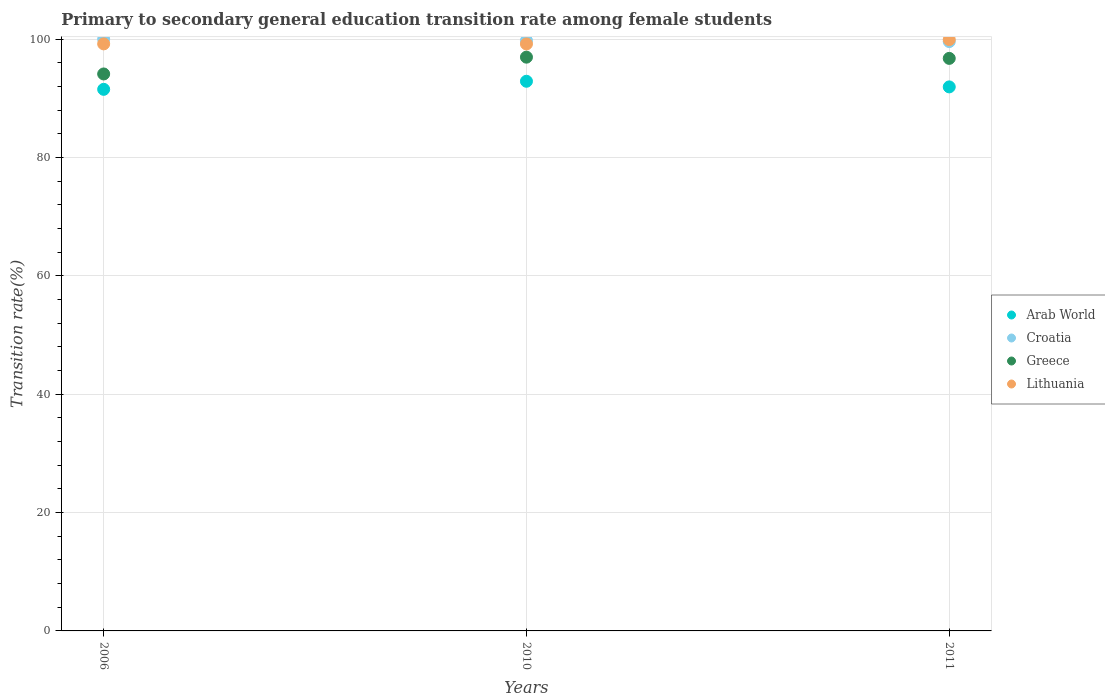What is the transition rate in Croatia in 2011?
Your answer should be very brief. 99.58. Across all years, what is the maximum transition rate in Greece?
Give a very brief answer. 96.95. Across all years, what is the minimum transition rate in Arab World?
Offer a terse response. 91.51. In which year was the transition rate in Lithuania minimum?
Your answer should be very brief. 2010. What is the total transition rate in Greece in the graph?
Provide a succinct answer. 287.79. What is the difference between the transition rate in Lithuania in 2010 and that in 2011?
Keep it short and to the point. -0.74. What is the difference between the transition rate in Arab World in 2011 and the transition rate in Croatia in 2010?
Offer a terse response. -7.83. What is the average transition rate in Croatia per year?
Your response must be concise. 99.78. In the year 2006, what is the difference between the transition rate in Greece and transition rate in Lithuania?
Provide a short and direct response. -5.08. In how many years, is the transition rate in Greece greater than 84 %?
Keep it short and to the point. 3. What is the ratio of the transition rate in Arab World in 2006 to that in 2010?
Provide a succinct answer. 0.99. Is the difference between the transition rate in Greece in 2006 and 2011 greater than the difference between the transition rate in Lithuania in 2006 and 2011?
Provide a succinct answer. No. What is the difference between the highest and the second highest transition rate in Croatia?
Give a very brief answer. 0.25. What is the difference between the highest and the lowest transition rate in Lithuania?
Provide a succinct answer. 0.74. Is the sum of the transition rate in Greece in 2010 and 2011 greater than the maximum transition rate in Lithuania across all years?
Your answer should be compact. Yes. Is it the case that in every year, the sum of the transition rate in Arab World and transition rate in Lithuania  is greater than the sum of transition rate in Croatia and transition rate in Greece?
Offer a very short reply. No. Does the transition rate in Lithuania monotonically increase over the years?
Make the answer very short. No. How many dotlines are there?
Offer a terse response. 4. What is the difference between two consecutive major ticks on the Y-axis?
Keep it short and to the point. 20. What is the title of the graph?
Offer a very short reply. Primary to secondary general education transition rate among female students. What is the label or title of the X-axis?
Ensure brevity in your answer.  Years. What is the label or title of the Y-axis?
Make the answer very short. Transition rate(%). What is the Transition rate(%) in Arab World in 2006?
Provide a succinct answer. 91.51. What is the Transition rate(%) in Greece in 2006?
Ensure brevity in your answer.  94.11. What is the Transition rate(%) of Lithuania in 2006?
Ensure brevity in your answer.  99.19. What is the Transition rate(%) of Arab World in 2010?
Your response must be concise. 92.87. What is the Transition rate(%) in Croatia in 2010?
Offer a terse response. 99.75. What is the Transition rate(%) of Greece in 2010?
Provide a succinct answer. 96.95. What is the Transition rate(%) of Lithuania in 2010?
Ensure brevity in your answer.  99.18. What is the Transition rate(%) in Arab World in 2011?
Your response must be concise. 91.92. What is the Transition rate(%) in Croatia in 2011?
Keep it short and to the point. 99.58. What is the Transition rate(%) in Greece in 2011?
Make the answer very short. 96.74. What is the Transition rate(%) in Lithuania in 2011?
Provide a succinct answer. 99.92. Across all years, what is the maximum Transition rate(%) of Arab World?
Your answer should be compact. 92.87. Across all years, what is the maximum Transition rate(%) of Greece?
Offer a very short reply. 96.95. Across all years, what is the maximum Transition rate(%) in Lithuania?
Provide a short and direct response. 99.92. Across all years, what is the minimum Transition rate(%) of Arab World?
Provide a succinct answer. 91.51. Across all years, what is the minimum Transition rate(%) of Croatia?
Offer a terse response. 99.58. Across all years, what is the minimum Transition rate(%) in Greece?
Provide a short and direct response. 94.11. Across all years, what is the minimum Transition rate(%) of Lithuania?
Provide a succinct answer. 99.18. What is the total Transition rate(%) of Arab World in the graph?
Ensure brevity in your answer.  276.31. What is the total Transition rate(%) of Croatia in the graph?
Keep it short and to the point. 299.33. What is the total Transition rate(%) in Greece in the graph?
Provide a succinct answer. 287.79. What is the total Transition rate(%) of Lithuania in the graph?
Make the answer very short. 298.29. What is the difference between the Transition rate(%) in Arab World in 2006 and that in 2010?
Your answer should be compact. -1.36. What is the difference between the Transition rate(%) of Croatia in 2006 and that in 2010?
Keep it short and to the point. 0.25. What is the difference between the Transition rate(%) in Greece in 2006 and that in 2010?
Keep it short and to the point. -2.84. What is the difference between the Transition rate(%) in Lithuania in 2006 and that in 2010?
Offer a terse response. 0.01. What is the difference between the Transition rate(%) in Arab World in 2006 and that in 2011?
Make the answer very short. -0.41. What is the difference between the Transition rate(%) in Croatia in 2006 and that in 2011?
Provide a short and direct response. 0.42. What is the difference between the Transition rate(%) of Greece in 2006 and that in 2011?
Provide a short and direct response. -2.63. What is the difference between the Transition rate(%) in Lithuania in 2006 and that in 2011?
Offer a terse response. -0.73. What is the difference between the Transition rate(%) of Arab World in 2010 and that in 2011?
Offer a terse response. 0.95. What is the difference between the Transition rate(%) in Croatia in 2010 and that in 2011?
Provide a short and direct response. 0.17. What is the difference between the Transition rate(%) of Greece in 2010 and that in 2011?
Give a very brief answer. 0.21. What is the difference between the Transition rate(%) of Lithuania in 2010 and that in 2011?
Ensure brevity in your answer.  -0.74. What is the difference between the Transition rate(%) of Arab World in 2006 and the Transition rate(%) of Croatia in 2010?
Your answer should be very brief. -8.24. What is the difference between the Transition rate(%) in Arab World in 2006 and the Transition rate(%) in Greece in 2010?
Provide a succinct answer. -5.44. What is the difference between the Transition rate(%) in Arab World in 2006 and the Transition rate(%) in Lithuania in 2010?
Provide a short and direct response. -7.67. What is the difference between the Transition rate(%) in Croatia in 2006 and the Transition rate(%) in Greece in 2010?
Provide a succinct answer. 3.05. What is the difference between the Transition rate(%) in Croatia in 2006 and the Transition rate(%) in Lithuania in 2010?
Provide a short and direct response. 0.82. What is the difference between the Transition rate(%) in Greece in 2006 and the Transition rate(%) in Lithuania in 2010?
Your response must be concise. -5.07. What is the difference between the Transition rate(%) in Arab World in 2006 and the Transition rate(%) in Croatia in 2011?
Make the answer very short. -8.07. What is the difference between the Transition rate(%) in Arab World in 2006 and the Transition rate(%) in Greece in 2011?
Give a very brief answer. -5.23. What is the difference between the Transition rate(%) in Arab World in 2006 and the Transition rate(%) in Lithuania in 2011?
Your answer should be very brief. -8.41. What is the difference between the Transition rate(%) of Croatia in 2006 and the Transition rate(%) of Greece in 2011?
Offer a terse response. 3.26. What is the difference between the Transition rate(%) of Croatia in 2006 and the Transition rate(%) of Lithuania in 2011?
Offer a terse response. 0.08. What is the difference between the Transition rate(%) in Greece in 2006 and the Transition rate(%) in Lithuania in 2011?
Your response must be concise. -5.81. What is the difference between the Transition rate(%) of Arab World in 2010 and the Transition rate(%) of Croatia in 2011?
Make the answer very short. -6.71. What is the difference between the Transition rate(%) of Arab World in 2010 and the Transition rate(%) of Greece in 2011?
Your response must be concise. -3.87. What is the difference between the Transition rate(%) in Arab World in 2010 and the Transition rate(%) in Lithuania in 2011?
Keep it short and to the point. -7.04. What is the difference between the Transition rate(%) in Croatia in 2010 and the Transition rate(%) in Greece in 2011?
Offer a terse response. 3.01. What is the difference between the Transition rate(%) in Croatia in 2010 and the Transition rate(%) in Lithuania in 2011?
Your answer should be compact. -0.17. What is the difference between the Transition rate(%) of Greece in 2010 and the Transition rate(%) of Lithuania in 2011?
Ensure brevity in your answer.  -2.97. What is the average Transition rate(%) in Arab World per year?
Give a very brief answer. 92.1. What is the average Transition rate(%) of Croatia per year?
Your response must be concise. 99.78. What is the average Transition rate(%) of Greece per year?
Your answer should be very brief. 95.93. What is the average Transition rate(%) of Lithuania per year?
Offer a very short reply. 99.43. In the year 2006, what is the difference between the Transition rate(%) in Arab World and Transition rate(%) in Croatia?
Offer a very short reply. -8.49. In the year 2006, what is the difference between the Transition rate(%) of Arab World and Transition rate(%) of Greece?
Your response must be concise. -2.6. In the year 2006, what is the difference between the Transition rate(%) in Arab World and Transition rate(%) in Lithuania?
Provide a short and direct response. -7.68. In the year 2006, what is the difference between the Transition rate(%) of Croatia and Transition rate(%) of Greece?
Give a very brief answer. 5.89. In the year 2006, what is the difference between the Transition rate(%) of Croatia and Transition rate(%) of Lithuania?
Make the answer very short. 0.81. In the year 2006, what is the difference between the Transition rate(%) of Greece and Transition rate(%) of Lithuania?
Offer a terse response. -5.08. In the year 2010, what is the difference between the Transition rate(%) of Arab World and Transition rate(%) of Croatia?
Make the answer very short. -6.88. In the year 2010, what is the difference between the Transition rate(%) in Arab World and Transition rate(%) in Greece?
Offer a very short reply. -4.07. In the year 2010, what is the difference between the Transition rate(%) in Arab World and Transition rate(%) in Lithuania?
Provide a succinct answer. -6.3. In the year 2010, what is the difference between the Transition rate(%) of Croatia and Transition rate(%) of Greece?
Provide a succinct answer. 2.81. In the year 2010, what is the difference between the Transition rate(%) in Croatia and Transition rate(%) in Lithuania?
Make the answer very short. 0.57. In the year 2010, what is the difference between the Transition rate(%) in Greece and Transition rate(%) in Lithuania?
Keep it short and to the point. -2.23. In the year 2011, what is the difference between the Transition rate(%) in Arab World and Transition rate(%) in Croatia?
Your response must be concise. -7.66. In the year 2011, what is the difference between the Transition rate(%) of Arab World and Transition rate(%) of Greece?
Your answer should be very brief. -4.82. In the year 2011, what is the difference between the Transition rate(%) in Arab World and Transition rate(%) in Lithuania?
Offer a very short reply. -8. In the year 2011, what is the difference between the Transition rate(%) of Croatia and Transition rate(%) of Greece?
Give a very brief answer. 2.84. In the year 2011, what is the difference between the Transition rate(%) in Croatia and Transition rate(%) in Lithuania?
Your response must be concise. -0.34. In the year 2011, what is the difference between the Transition rate(%) in Greece and Transition rate(%) in Lithuania?
Your response must be concise. -3.18. What is the ratio of the Transition rate(%) of Arab World in 2006 to that in 2010?
Provide a succinct answer. 0.99. What is the ratio of the Transition rate(%) in Croatia in 2006 to that in 2010?
Ensure brevity in your answer.  1. What is the ratio of the Transition rate(%) in Greece in 2006 to that in 2010?
Your response must be concise. 0.97. What is the ratio of the Transition rate(%) in Lithuania in 2006 to that in 2010?
Give a very brief answer. 1. What is the ratio of the Transition rate(%) of Arab World in 2006 to that in 2011?
Your answer should be compact. 1. What is the ratio of the Transition rate(%) in Croatia in 2006 to that in 2011?
Your answer should be compact. 1. What is the ratio of the Transition rate(%) in Greece in 2006 to that in 2011?
Offer a terse response. 0.97. What is the ratio of the Transition rate(%) of Arab World in 2010 to that in 2011?
Keep it short and to the point. 1.01. What is the ratio of the Transition rate(%) of Croatia in 2010 to that in 2011?
Your answer should be compact. 1. What is the ratio of the Transition rate(%) in Lithuania in 2010 to that in 2011?
Offer a very short reply. 0.99. What is the difference between the highest and the second highest Transition rate(%) of Arab World?
Offer a very short reply. 0.95. What is the difference between the highest and the second highest Transition rate(%) of Croatia?
Offer a very short reply. 0.25. What is the difference between the highest and the second highest Transition rate(%) of Greece?
Provide a short and direct response. 0.21. What is the difference between the highest and the second highest Transition rate(%) of Lithuania?
Your answer should be very brief. 0.73. What is the difference between the highest and the lowest Transition rate(%) in Arab World?
Provide a short and direct response. 1.36. What is the difference between the highest and the lowest Transition rate(%) of Croatia?
Give a very brief answer. 0.42. What is the difference between the highest and the lowest Transition rate(%) of Greece?
Keep it short and to the point. 2.84. What is the difference between the highest and the lowest Transition rate(%) of Lithuania?
Keep it short and to the point. 0.74. 